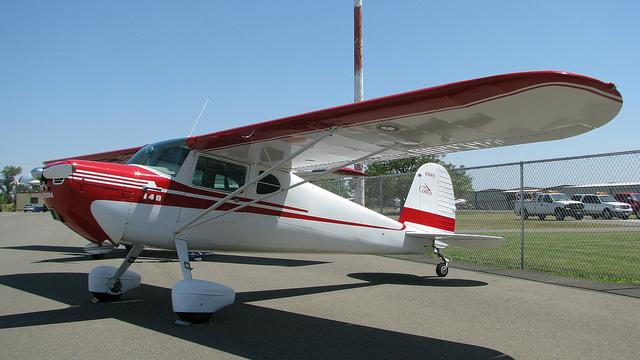How many wheels are used on the bottom of this aircraft? three 